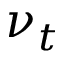<formula> <loc_0><loc_0><loc_500><loc_500>\nu _ { t }</formula> 